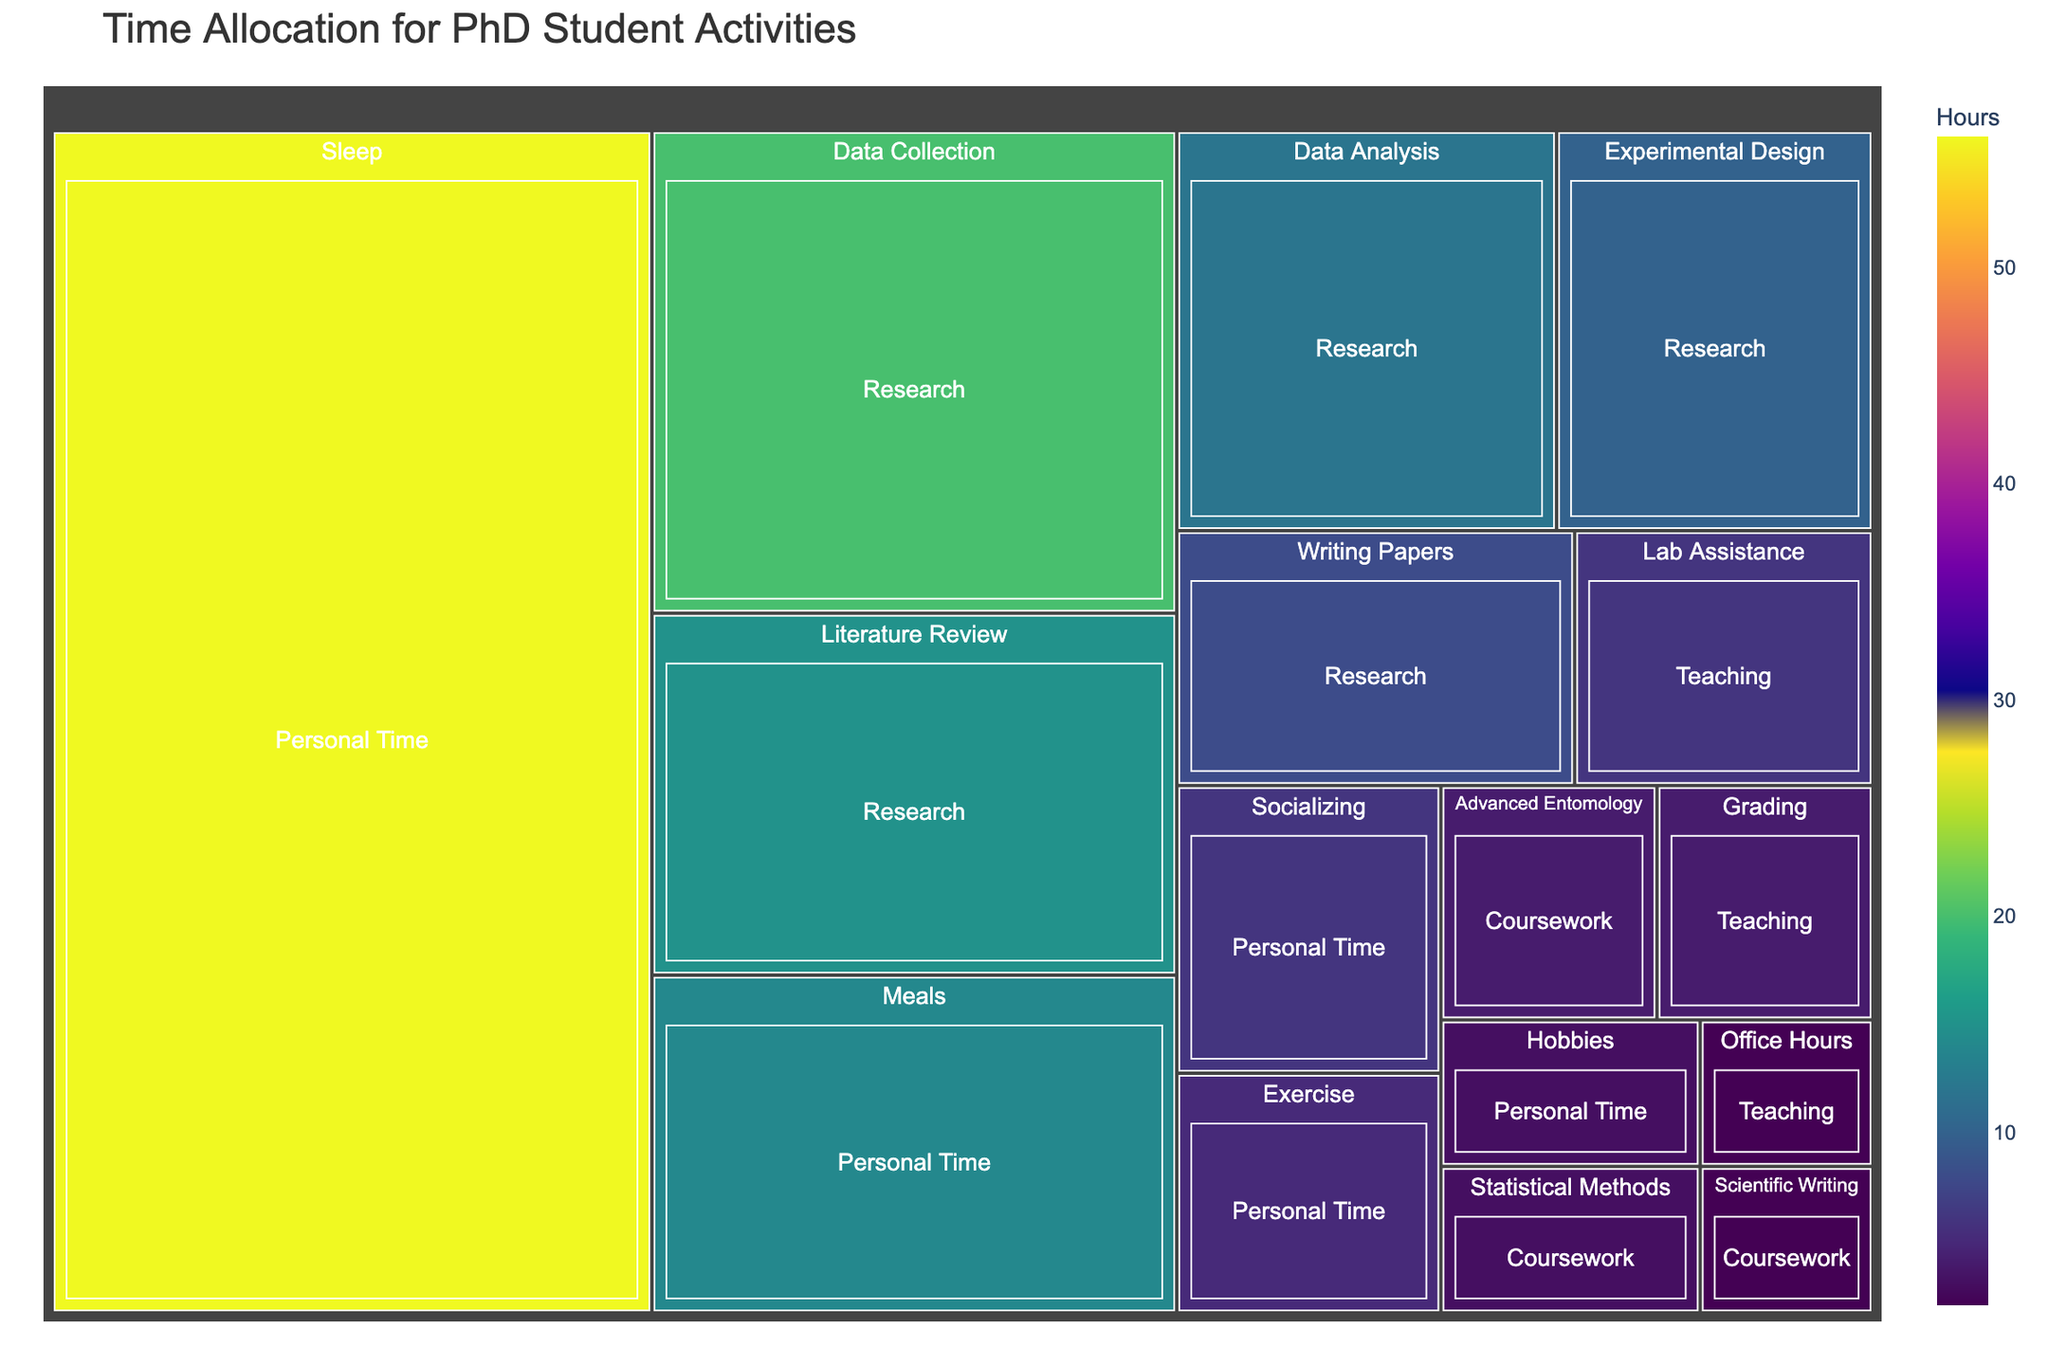What's the largest category in terms of hours? The largest category in terms of hours can be seen by looking at the size of the tiles within each category and comparing them. The 'Personal Time' category includes substantial time allocations for activities such as Sleep, Meals, and Exercise, contributing to a large overall total. The other categories like Research, Coursework, and Teaching collectively have less total time compared to Personal Time.
Answer: Personal Time Which activity has the smallest time allocation? Scan the treemap to find the smallest tile representing an activity. The 'Scientific Writing' under the Coursework category has 2 hours, which is the smallest allocation compared to all other activities.
Answer: Scientific Writing How many hours are spent on teaching activities in total? Teaching hours can be found by summing up the hours allocated to each teaching activity. Lab Assistance is 6 hours, Grading is 4 hours, and Office Hours is 2 hours. Adding these up, 6 + 4 + 2 = 12.
Answer: 12 What's the difference in hours allocated to 'Sleep' and 'Research'? Identify the hours for Sleep and total hours for Research. Sleep has 56 hours, and Research's sub-activities sum to 65 hours (15 + 10 + 20 + 12 + 8). The difference is 65 - 56 = 9.
Answer: 9 Which research activity consumes the most time? Within the Research category, the largest tile represents 'Data Collection' with 20 hours.
Answer: Data Collection What proportion of the total allocated hours is spent on Research activities? Calculate total hours by adding all category hours: Research (65), Coursework (9), Teaching (12), and Personal Time (84), which sums to 170 hours. Proportion of Research is 65/170.
Answer: 0.382 (or 38.2%) Compare the hours allocated to 'Advanced Entomology' and 'Statistical Methods'. Which one has more and by how much? Advanced Entomology has 4 hours and Statistical Methods has 3 hours. The difference is 4 - 3 = 1 hour.
Answer: Advanced Entomology by 1 hour How much more time is allocated to 'Writing Papers' than 'Hobbies'? Writing Papers under Research has 8 hours, while Hobbies under Personal Time has 3 hours. The difference is 8 - 3 = 5 hours.
Answer: 5 hours Which category between 'Research' and 'Personal Time' has more activities? Count the activities in each category. Research has 5 activities while Personal Time has 5 activities. Both categories have the same number of activities.
Answer: Both the same If you combine hours spent on 'Lab Assistance' and 'Office Hours', is it greater than the time spent on 'Socializing'? Lab Assistance is 6 hours and Office Hours is 2 hours. Their sum is 6 + 2 = 8 hours. Socializing is 6 hours. Comparing these, 8 is greater than 6.
Answer: Yes, greater 